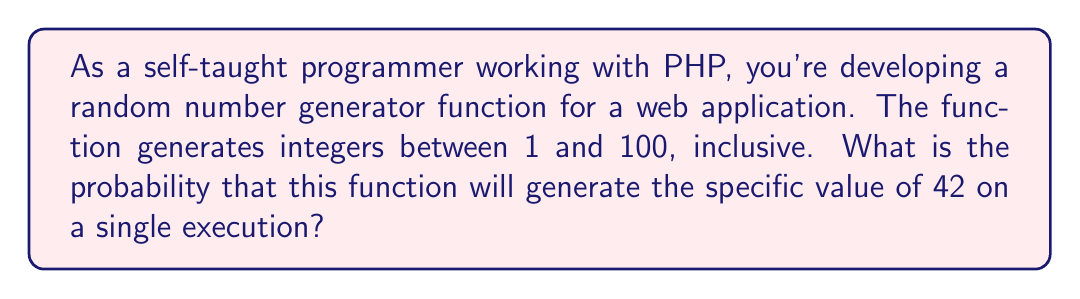Teach me how to tackle this problem. To solve this problem, we need to understand the concept of probability for equally likely outcomes. In this case, we have a random number generator that produces integers from 1 to 100, with each number having an equal chance of being selected.

The probability of a specific event occurring is calculated as:

$$ P(\text{event}) = \frac{\text{number of favorable outcomes}}{\text{total number of possible outcomes}} $$

In our scenario:
1. The favorable outcome is generating the number 42.
2. The total number of possible outcomes is 100 (integers from 1 to 100).

Therefore, the probability of generating 42 is:

$$ P(42) = \frac{1}{100} = 0.01 $$

This means there is a 1% chance of generating the number 42 on a single execution of the random number generator function.

In PHP, you might implement such a function using the `rand()` function:

```php
function generateRandomNumber() {
    return rand(1, 100);
}
```

The probability remains the same regardless of how many times you run the function, as each execution is independent of the others.
Answer: The probability of the random number generator producing the specific value of 42 is $\frac{1}{100}$ or $0.01$ or $1\%$. 